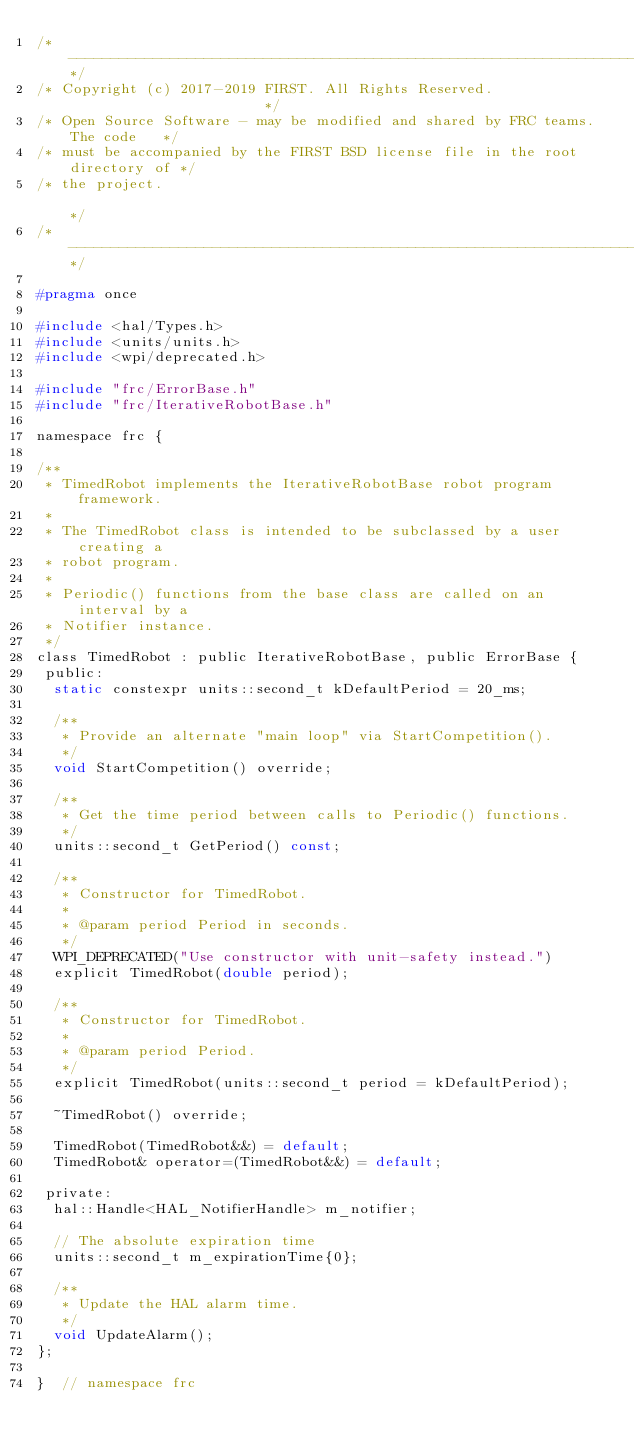Convert code to text. <code><loc_0><loc_0><loc_500><loc_500><_C_>/*----------------------------------------------------------------------------*/
/* Copyright (c) 2017-2019 FIRST. All Rights Reserved.                        */
/* Open Source Software - may be modified and shared by FRC teams. The code   */
/* must be accompanied by the FIRST BSD license file in the root directory of */
/* the project.                                                               */
/*----------------------------------------------------------------------------*/

#pragma once

#include <hal/Types.h>
#include <units/units.h>
#include <wpi/deprecated.h>

#include "frc/ErrorBase.h"
#include "frc/IterativeRobotBase.h"

namespace frc {

/**
 * TimedRobot implements the IterativeRobotBase robot program framework.
 *
 * The TimedRobot class is intended to be subclassed by a user creating a
 * robot program.
 *
 * Periodic() functions from the base class are called on an interval by a
 * Notifier instance.
 */
class TimedRobot : public IterativeRobotBase, public ErrorBase {
 public:
  static constexpr units::second_t kDefaultPeriod = 20_ms;

  /**
   * Provide an alternate "main loop" via StartCompetition().
   */
  void StartCompetition() override;

  /**
   * Get the time period between calls to Periodic() functions.
   */
  units::second_t GetPeriod() const;

  /**
   * Constructor for TimedRobot.
   *
   * @param period Period in seconds.
   */
  WPI_DEPRECATED("Use constructor with unit-safety instead.")
  explicit TimedRobot(double period);

  /**
   * Constructor for TimedRobot.
   *
   * @param period Period.
   */
  explicit TimedRobot(units::second_t period = kDefaultPeriod);

  ~TimedRobot() override;

  TimedRobot(TimedRobot&&) = default;
  TimedRobot& operator=(TimedRobot&&) = default;

 private:
  hal::Handle<HAL_NotifierHandle> m_notifier;

  // The absolute expiration time
  units::second_t m_expirationTime{0};

  /**
   * Update the HAL alarm time.
   */
  void UpdateAlarm();
};

}  // namespace frc
</code> 